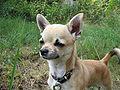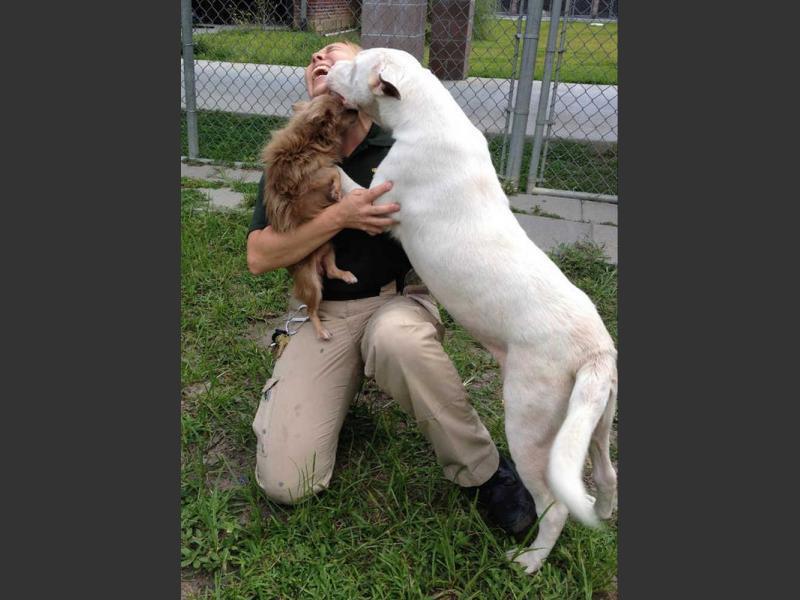The first image is the image on the left, the second image is the image on the right. For the images displayed, is the sentence "A chihuahua with its body turned toward the camera is baring its fangs." factually correct? Answer yes or no. No. The first image is the image on the left, the second image is the image on the right. Given the left and right images, does the statement "The right image contains no more than one dog." hold true? Answer yes or no. No. 